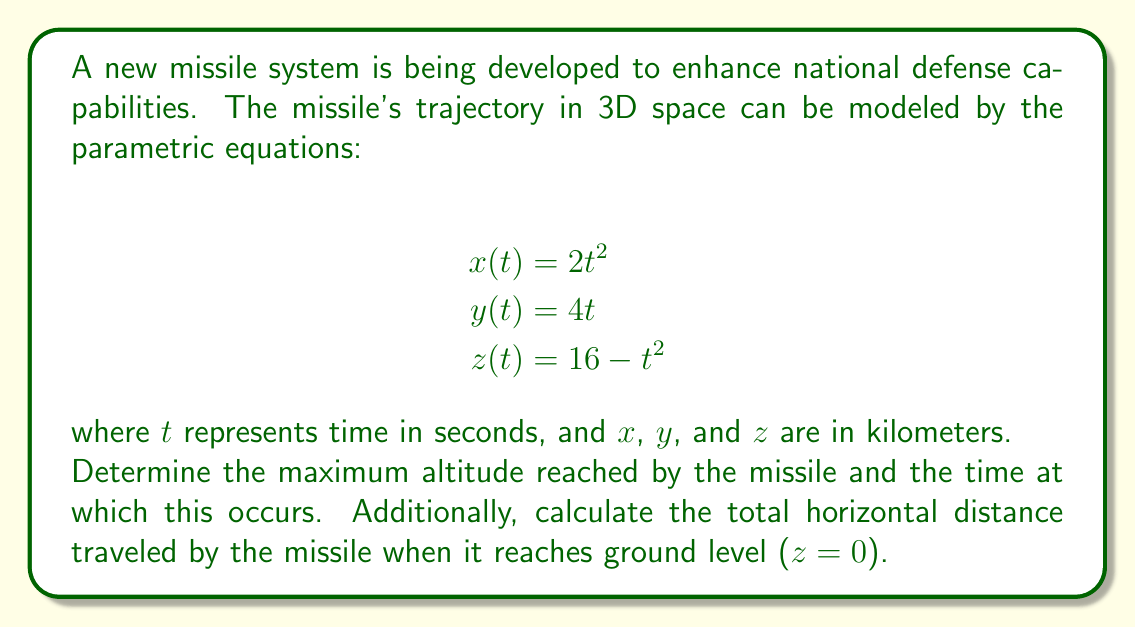Teach me how to tackle this problem. To solve this problem, we'll follow these steps:

1. Find the maximum altitude:
   The altitude is represented by the z-coordinate. To find its maximum, we need to determine when $\frac{dz}{dt} = 0$.

   $$\frac{dz}{dt} = -2t$$

   Setting this equal to zero:
   $$-2t = 0$$
   $$t = 0$$

   The second derivative $\frac{d^2z}{dt^2} = -2$ is negative, confirming this is a maximum.

   At $t = 0$, the maximum altitude is:
   $$z(0) = 16 - 0^2 = 16$$ km

2. Calculate the time when the missile reaches ground level:
   Ground level occurs when $z = 0$:

   $$16 - t^2 = 0$$
   $$t^2 = 16$$
   $$t = \pm 4$$

   Since time is positive in this context, $t = 4$ seconds.

3. Calculate the horizontal distance traveled:
   The horizontal distance is given by $\sqrt{x^2 + y^2}$ at $t = 4$:

   $$x(4) = 2(4^2) = 32$$ km
   $$y(4) = 4(4) = 16$$ km

   Total horizontal distance:
   $$\sqrt{32^2 + 16^2} = \sqrt{1024 + 256} = \sqrt{1280} = 8\sqrt{20}$$ km
Answer: The missile reaches a maximum altitude of 16 km at t = 0 seconds. The total horizontal distance traveled when the missile reaches ground level is $8\sqrt{20}$ km (approximately 35.78 km). 